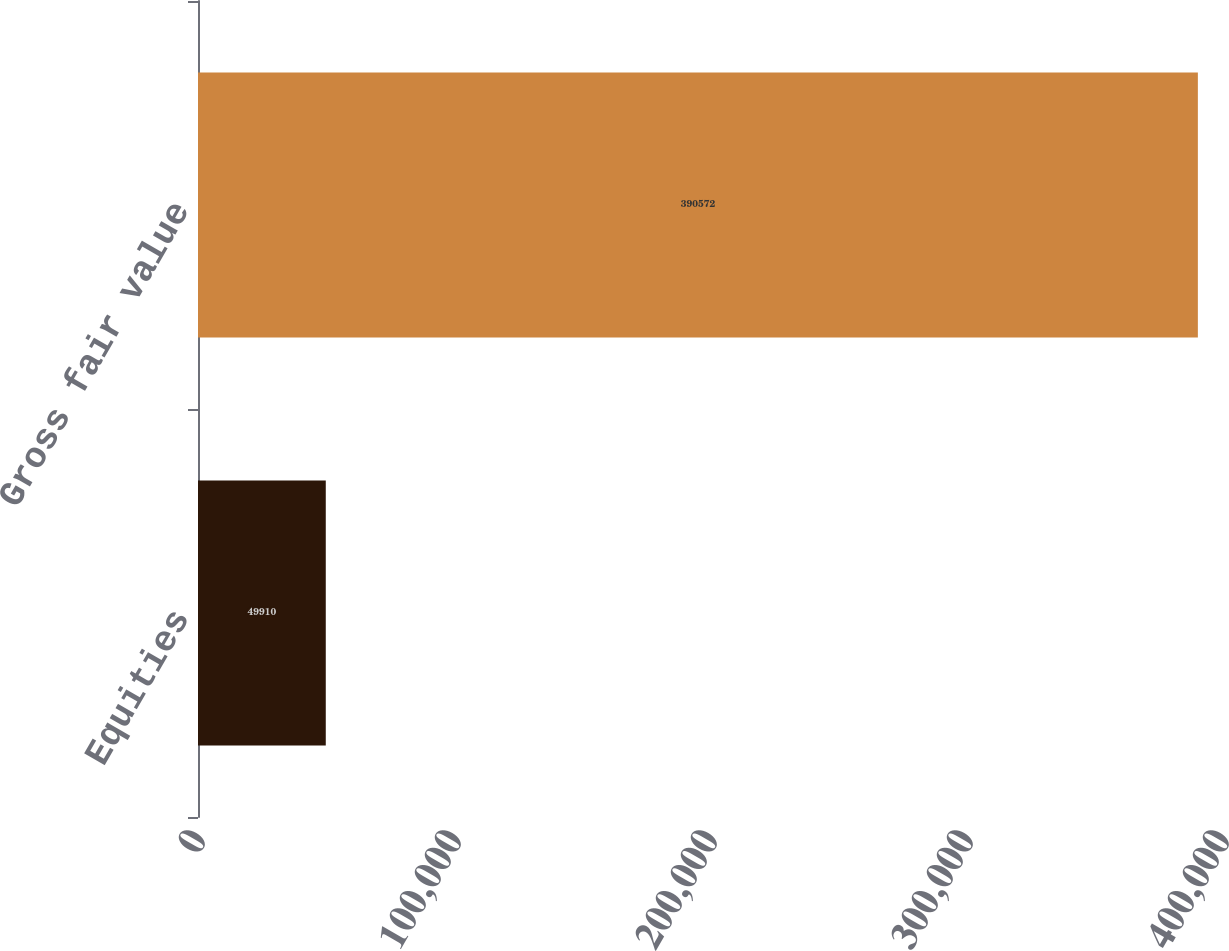<chart> <loc_0><loc_0><loc_500><loc_500><bar_chart><fcel>Equities<fcel>Gross fair value<nl><fcel>49910<fcel>390572<nl></chart> 